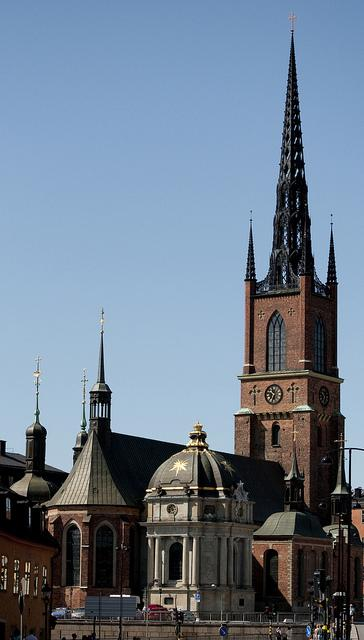What color are the little stars on top of the dome building at the church? Please explain your reasoning. gold. The color is gold. 